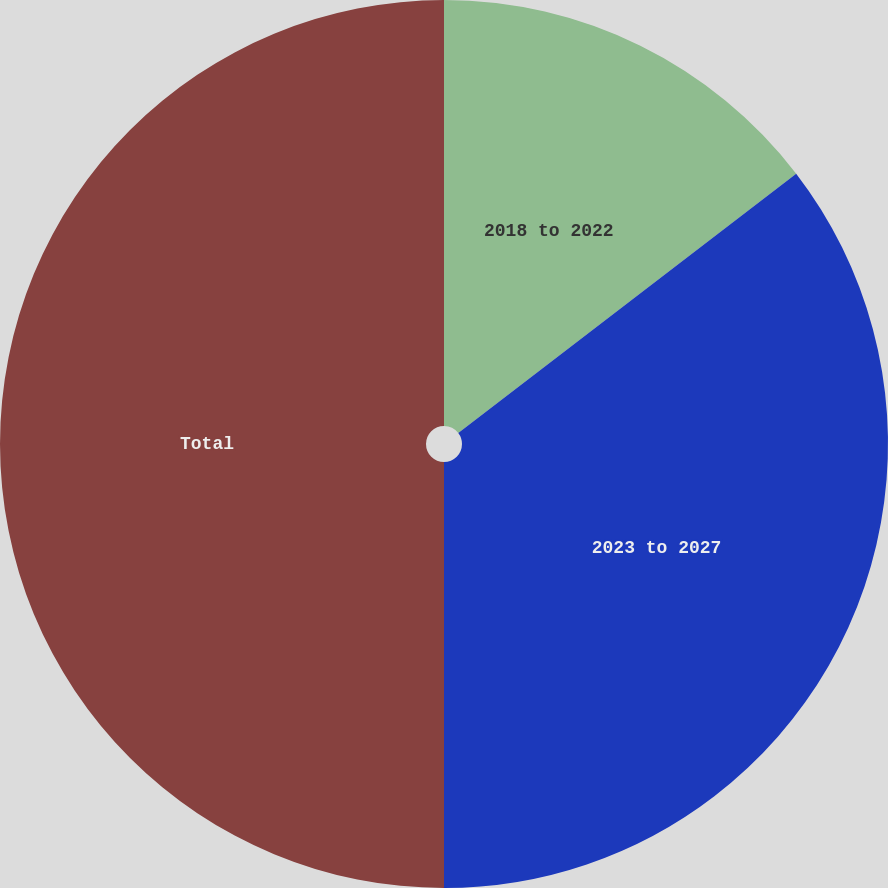<chart> <loc_0><loc_0><loc_500><loc_500><pie_chart><fcel>2018 to 2022<fcel>2023 to 2027<fcel>Total<nl><fcel>14.58%<fcel>35.42%<fcel>50.0%<nl></chart> 